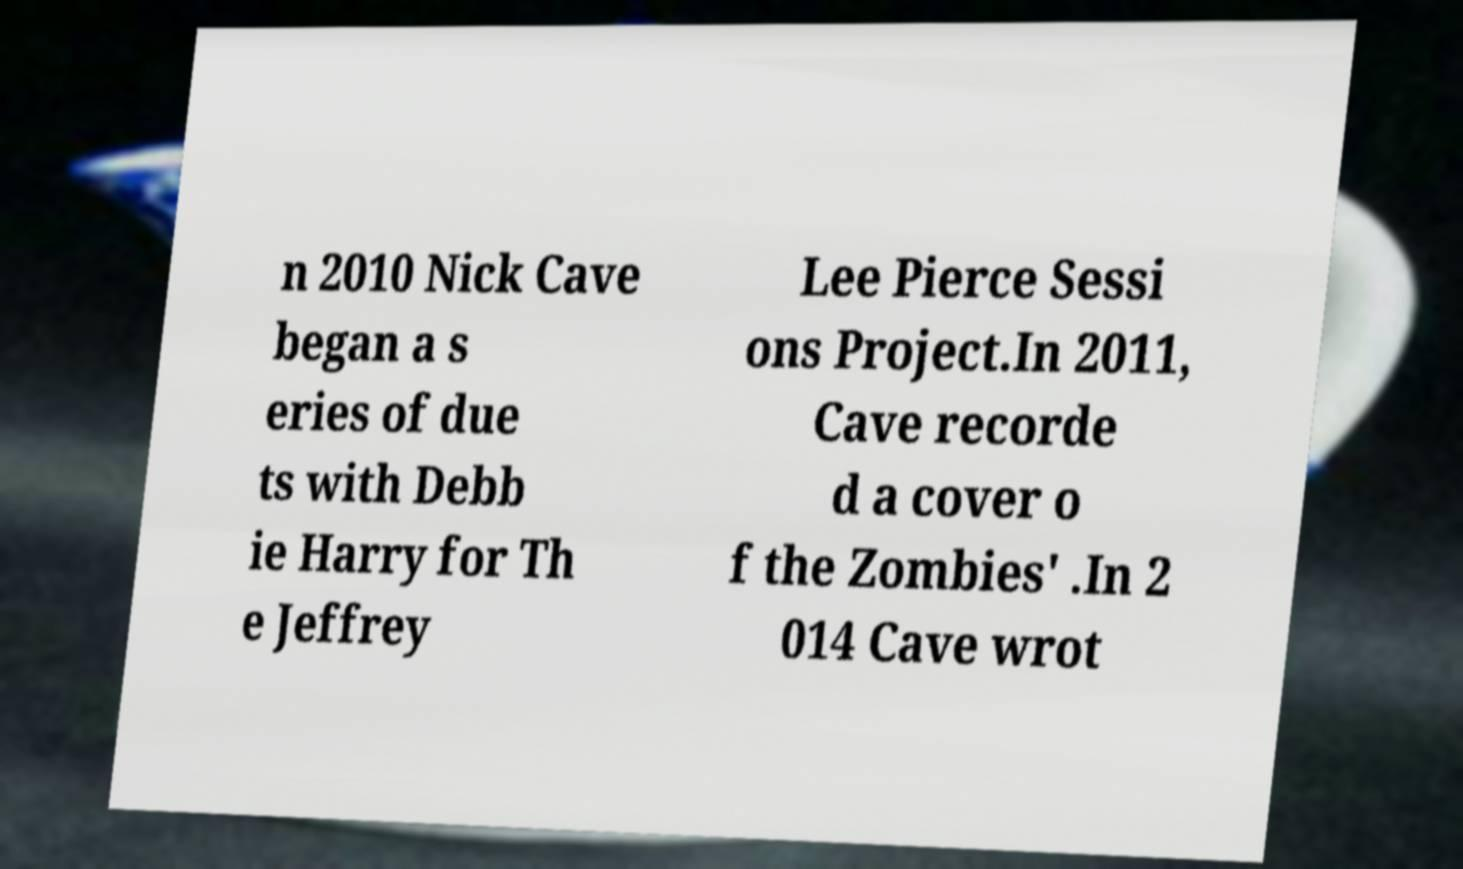What messages or text are displayed in this image? I need them in a readable, typed format. n 2010 Nick Cave began a s eries of due ts with Debb ie Harry for Th e Jeffrey Lee Pierce Sessi ons Project.In 2011, Cave recorde d a cover o f the Zombies' .In 2 014 Cave wrot 